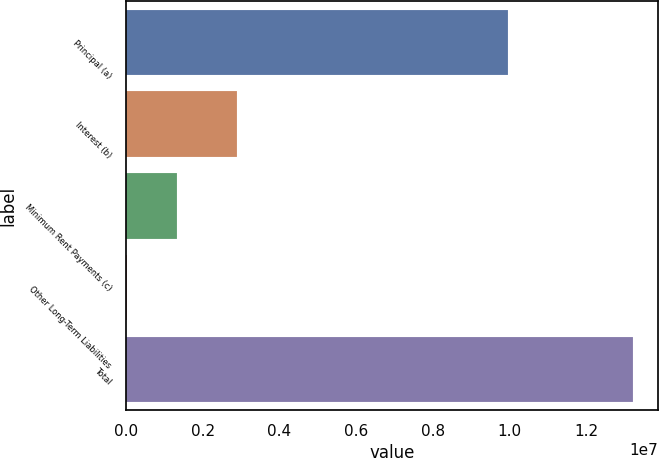<chart> <loc_0><loc_0><loc_500><loc_500><bar_chart><fcel>Principal (a)<fcel>Interest (b)<fcel>Minimum Rent Payments (c)<fcel>Other Long-Term Liabilities<fcel>Total<nl><fcel>9.94808e+06<fcel>2.90516e+06<fcel>1.33703e+06<fcel>17248<fcel>1.32151e+07<nl></chart> 